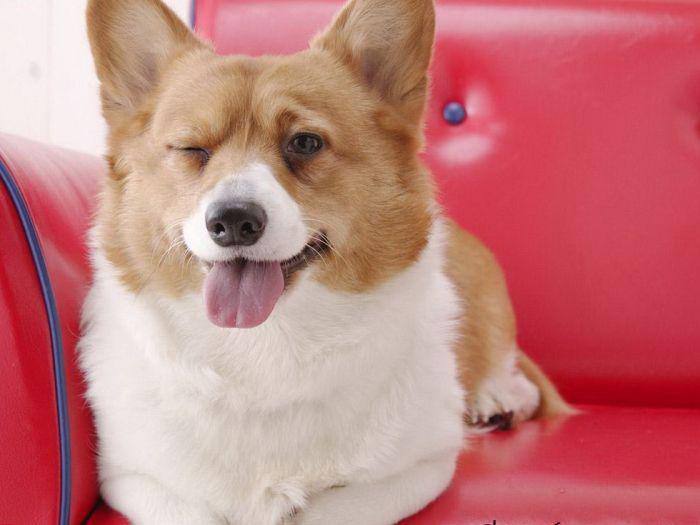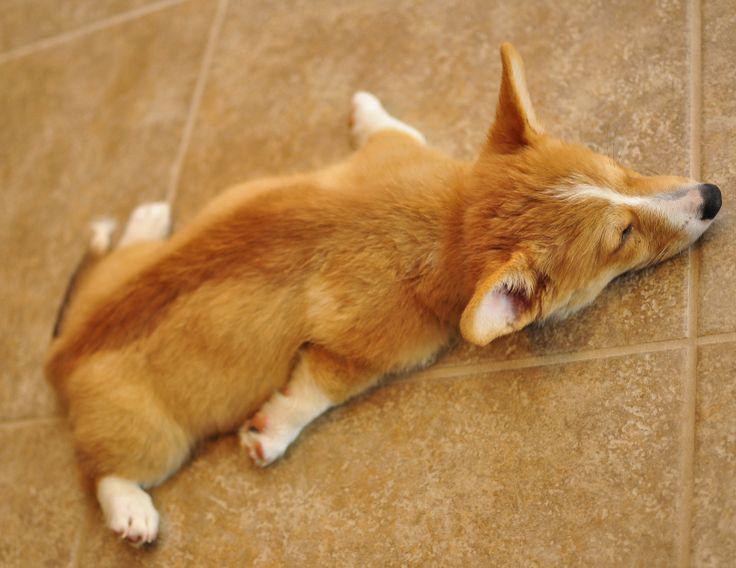The first image is the image on the left, the second image is the image on the right. Evaluate the accuracy of this statement regarding the images: "There are three dogs in total.". Is it true? Answer yes or no. No. The first image is the image on the left, the second image is the image on the right. Considering the images on both sides, is "An image shows one orange-and-white dog, which is sprawling flat on its belly." valid? Answer yes or no. Yes. 